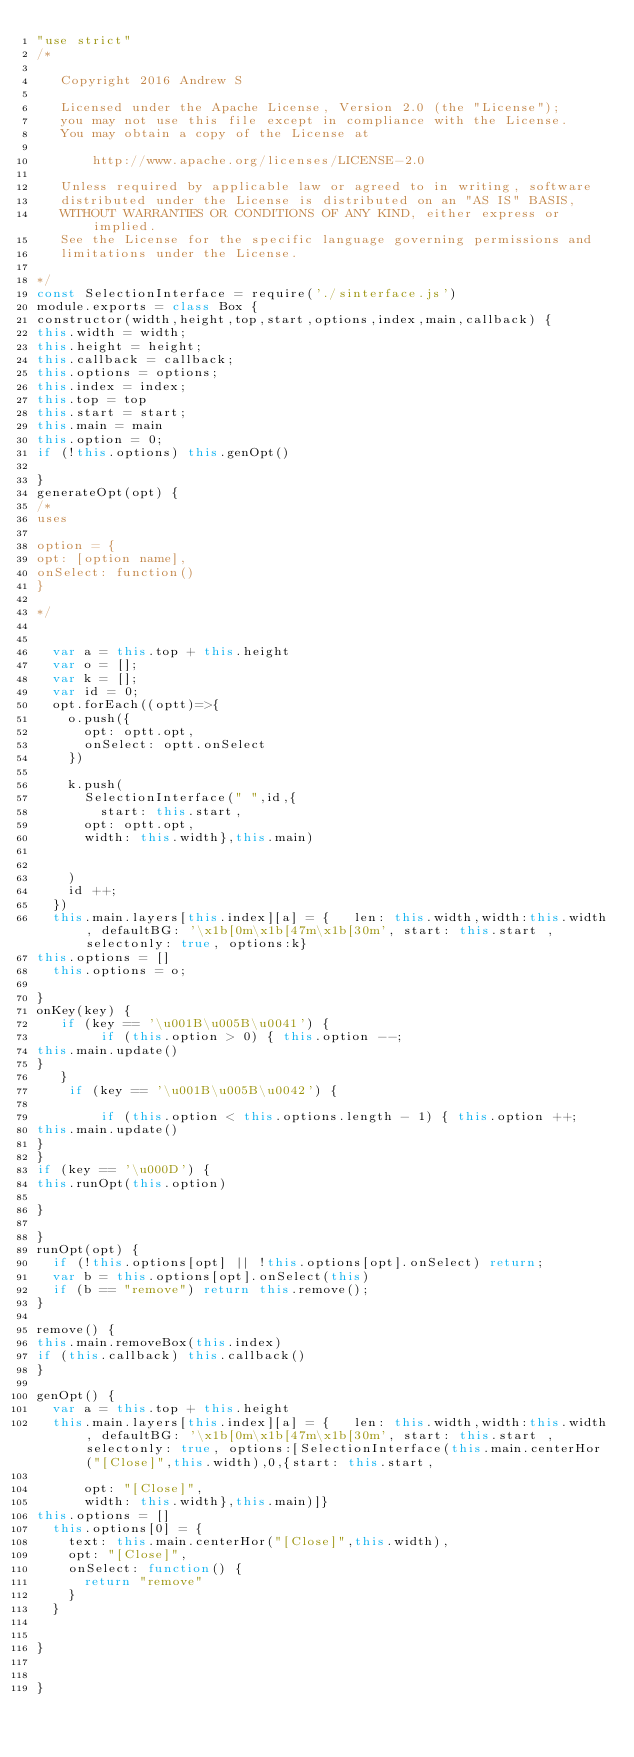Convert code to text. <code><loc_0><loc_0><loc_500><loc_500><_JavaScript_>"use strict"
/*

   Copyright 2016 Andrew S

   Licensed under the Apache License, Version 2.0 (the "License");
   you may not use this file except in compliance with the License.
   You may obtain a copy of the License at

       http://www.apache.org/licenses/LICENSE-2.0

   Unless required by applicable law or agreed to in writing, software
   distributed under the License is distributed on an "AS IS" BASIS,
   WITHOUT WARRANTIES OR CONDITIONS OF ANY KIND, either express or implied.
   See the License for the specific language governing permissions and
   limitations under the License.

*/
const SelectionInterface = require('./sinterface.js')
module.exports = class Box {
constructor(width,height,top,start,options,index,main,callback) {
this.width = width;
this.height = height;
this.callback = callback;
this.options = options;
this.index = index;
this.top = top
this.start = start;
this.main = main
this.option = 0;
if (!this.options) this.genOpt()
  
}
generateOpt(opt) {
/*
uses

option = {
opt: [option name],
onSelect: function()
}

*/


  var a = this.top + this.height
  var o = [];
  var k = [];
  var id = 0;
  opt.forEach((optt)=>{
    o.push({
      opt: optt.opt,
      onSelect: optt.onSelect
    })

    k.push(
      SelectionInterface(" ",id,{
        start: this.start,
      opt: optt.opt,
      width: this.width},this.main)
      
      
    )
    id ++;
  })
  this.main.layers[this.index][a] = {   len: this.width,width:this.width, defaultBG: '\x1b[0m\x1b[47m\x1b[30m', start: this.start ,selectonly: true, options:k}
this.options = []
  this.options = o;
  
}
onKey(key) {
   if (key == '\u001B\u005B\u0041') {
        if (this.option > 0) { this.option --;
this.main.update()    
}
   }
    if (key == '\u001B\u005B\u0042') {

        if (this.option < this.options.length - 1) { this.option ++; 
this.main.update()    
}
}
if (key == '\u000D') {
this.runOpt(this.option)

} 
  
}
runOpt(opt) {
  if (!this.options[opt] || !this.options[opt].onSelect) return;
  var b = this.options[opt].onSelect(this)
  if (b == "remove") return this.remove();
}

remove() {
this.main.removeBox(this.index)
if (this.callback) this.callback()
}

genOpt() {
  var a = this.top + this.height
  this.main.layers[this.index][a] = {   len: this.width,width:this.width, defaultBG: '\x1b[0m\x1b[47m\x1b[30m', start: this.start ,selectonly: true, options:[SelectionInterface(this.main.centerHor("[Close]",this.width),0,{start: this.start,
   
      opt: "[Close]",
      width: this.width},this.main)]}
this.options = []
  this.options[0] = {
    text: this.main.centerHor("[Close]",this.width),
    opt: "[Close]",
    onSelect: function() {
      return "remove"
    }
  }
  
  
}


}
</code> 